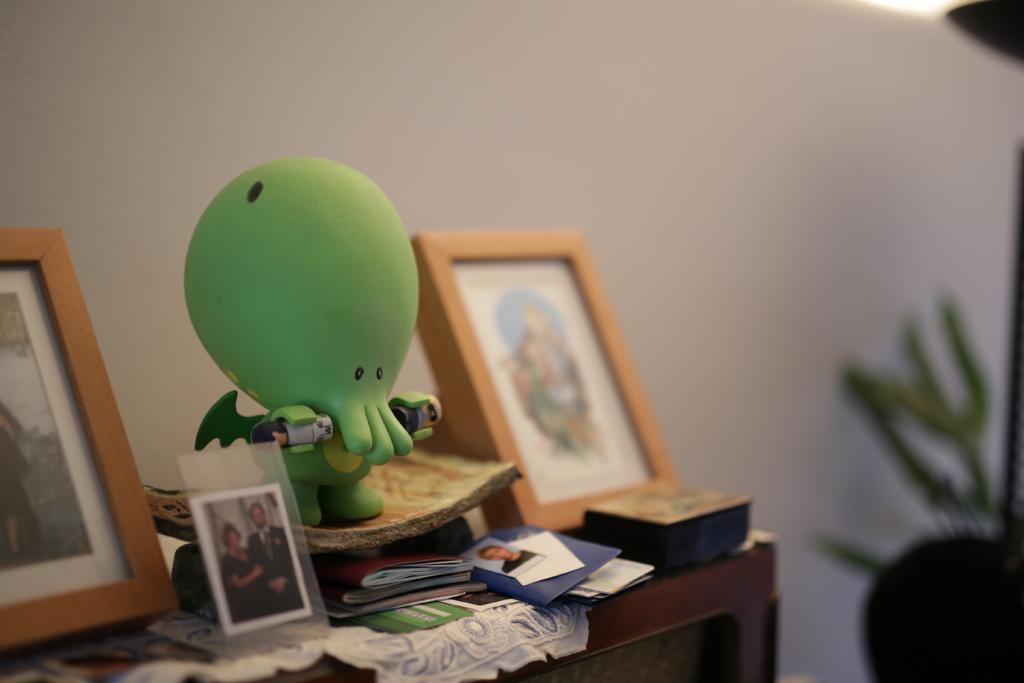Describe this image in one or two sentences. In this image we can see photo frames, toy, books, photos and cloth on a table. Behind the toy we can see a wall. The background of the image is blurred. 